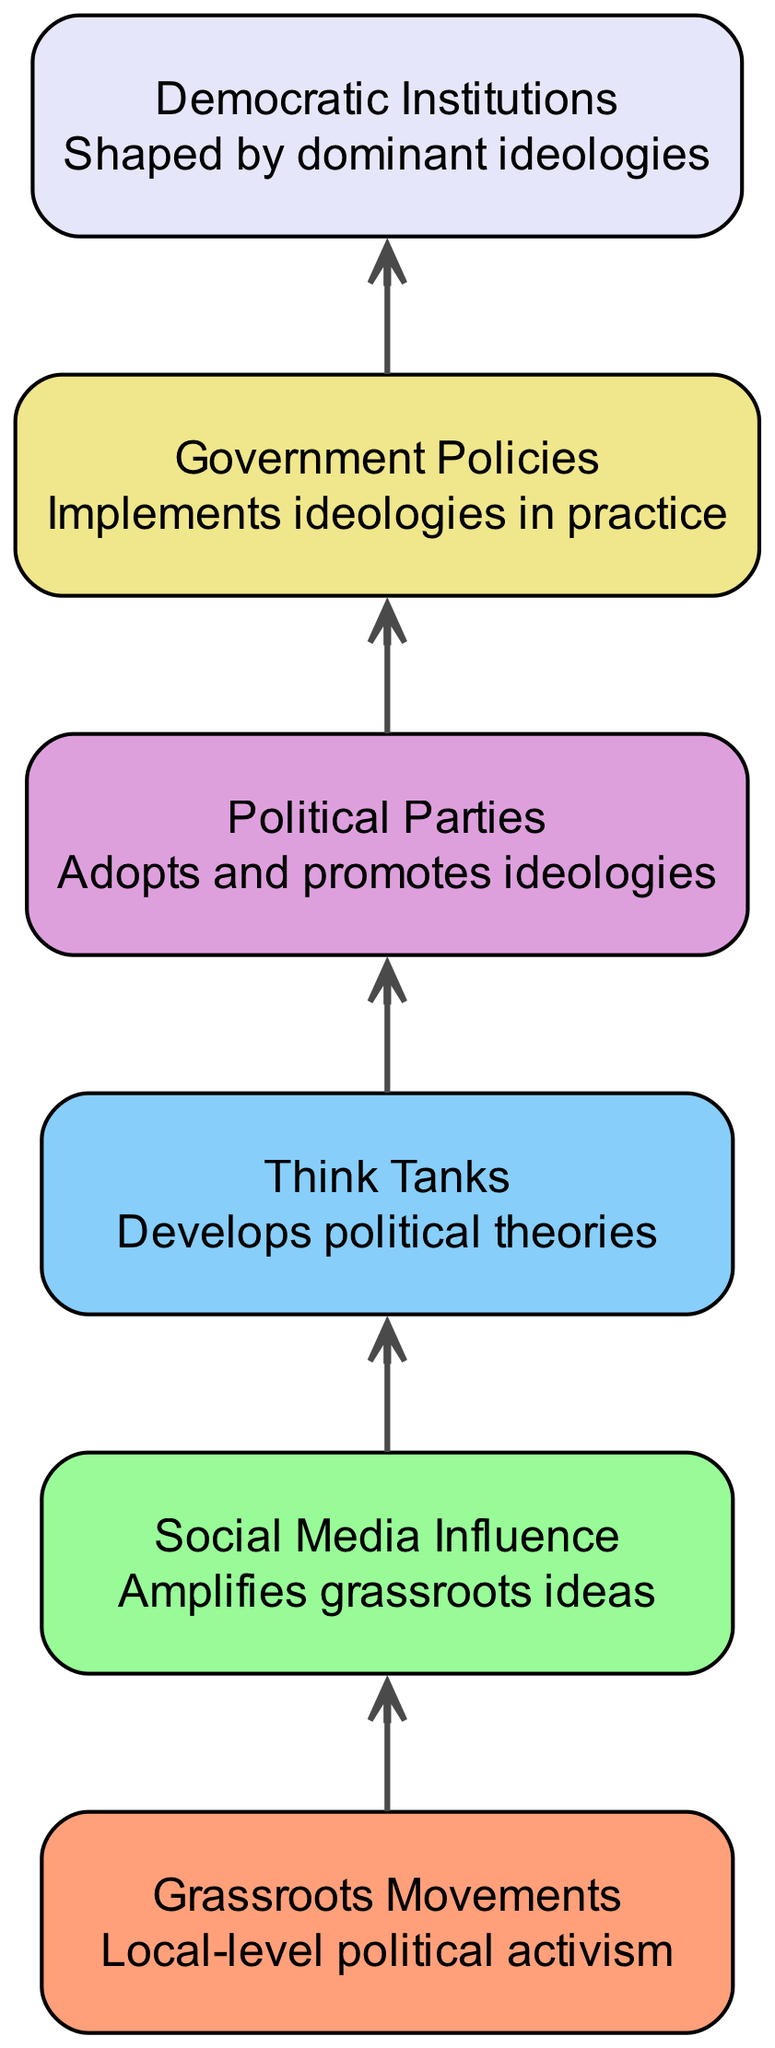What is the base element in the food chain? The base element connects to the first tier of the food chain, which represents the origin of influence in political ideologies. According to the diagram, the base element is "Grassroots Movements".
Answer: Grassroots Movements How many nodes are in the diagram? To determine the number of nodes, we can simply count each unique element displayed in the food chain. The diagram shows a total of six elements.
Answer: 6 What influences the development of political theories? The arrow indicates a direct relationship between "Social Media Influence" and "Think Tanks". "Social Media Influence" feeds into "Think Tanks", indicating it is the source that influences their development.
Answer: Social Media Influence Which element directly implements ideologies in practice? The diagram shows that "Government Policies" is the element that directly consumes the "Political Parties" element, which means it is responsible for implementing ideologies in practice.
Answer: Government Policies What are the top entities shaped by dominant ideologies? The highest level in the hierarchy, or the top element, is "Democratic Institutions". This is indicated as the peak of the food chain where ideologies manifest at an institutional level.
Answer: Democratic Institutions How many edges are connecting to the "Political Parties" node? To find the number of edges connected to "Political Parties", we look at the incoming arrows. The "Political Parties" node has one edge coming from "Think Tanks".
Answer: 1 What is the relationship between "Grassroots Movements" and "Democratic Institutions"? The relationship is indirect; "Grassroots Movements" influence "Social Media Influence", which in turn progresses through the hierarchy to eventually shape "Democratic Institutions". Thus, the connection is mediated through multiple nodes.
Answer: Indirect Which element amplifies grassroots ideas? The diagram shows that "Social Media Influence" is the element that directly amplifies ideas originating from "Grassroots Movements". This is evident from the consumption arrow flowing from "Grassroots Movements" to "Social Media Influence".
Answer: Social Media Influence What is the overall significance of "Think Tanks" in the food chain? "Think Tanks" play a crucial role by consuming information from "Social Media Influence" and producing political theories that are then adopted by "Political Parties", making them essential for ideological development.
Answer: Produces political theories 